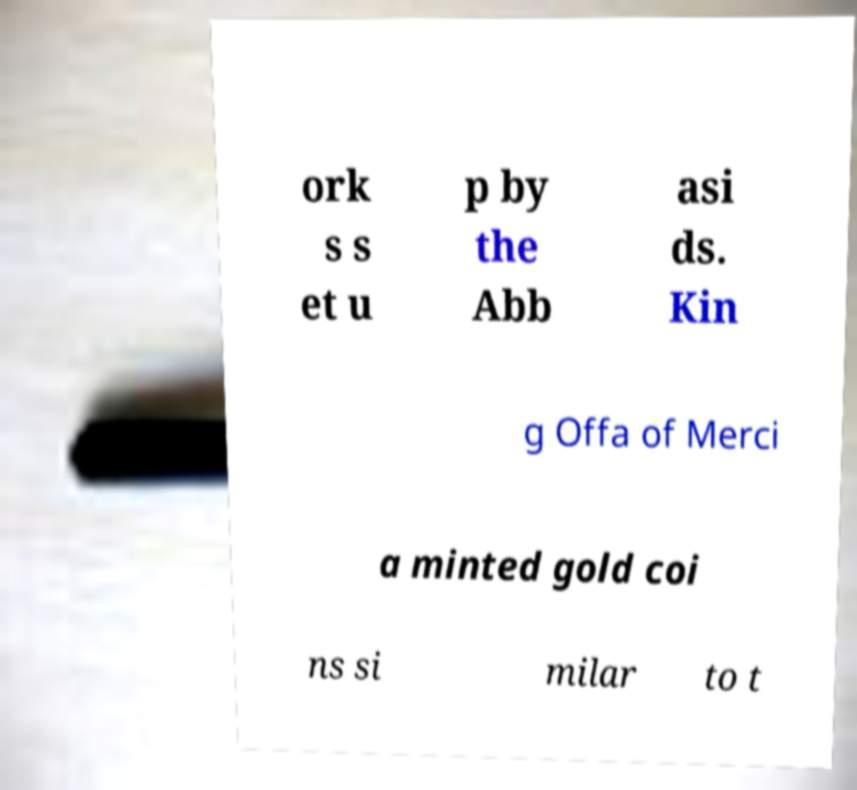I need the written content from this picture converted into text. Can you do that? ork s s et u p by the Abb asi ds. Kin g Offa of Merci a minted gold coi ns si milar to t 